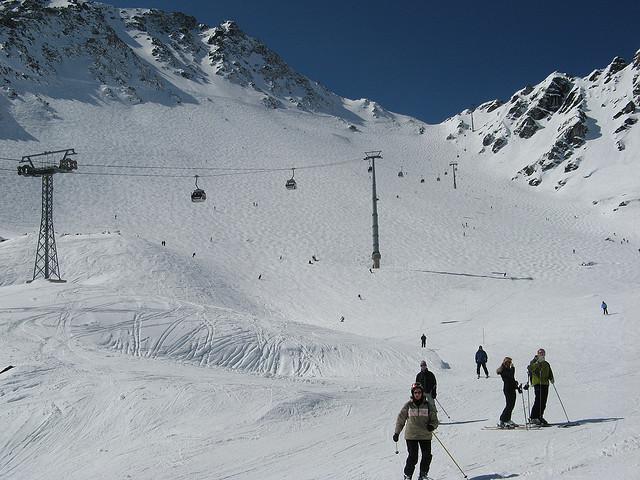Are these men friends?
Quick response, please. Yes. Is there a ski lift?
Concise answer only. Yes. What carries the skiers to the top of the mountain?
Write a very short answer. Ski lift. How many people are in the photo?
Concise answer only. 7. How many people are in this photo?
Short answer required. 7. How many skiers are in the picture?
Write a very short answer. 4. What is high in the photo?
Quick response, please. Mountain. 